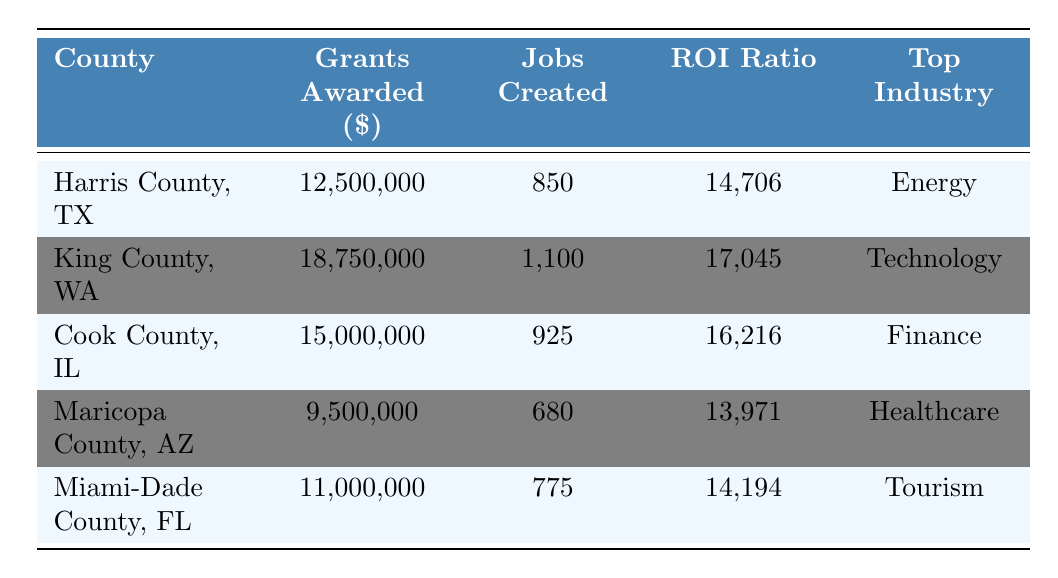What is the total amount of grants awarded across all counties? To find the total grants awarded, add the grants for each county: 12,500,000 + 18,750,000 + 15,000,000 + 9,500,000 + 11,000,000 = 66,750,000.
Answer: 66,750,000 Which county received the highest amount of grants? Look at the grants awarded column and identify the maximum value, which is 18,750,000 for King County, WA.
Answer: King County, WA What is the average number of jobs created across the counties? To find the average, sum the jobs created: 850 + 1100 + 925 + 680 + 775 = 4330, then divide by the number of counties (5): 4330 / 5 = 866.
Answer: 866 Which county has the highest ROI ratio? The highest ROI ratio is found by comparing the ROI ratios of each county. The maximum is 17,045 for King County, WA.
Answer: King County, WA Is the top industry for Maricopa County, AZ healthcare? Checking the table, the top industry for Maricopa County, AZ is indeed healthcare.
Answer: Yes What is the relationship between grants awarded and jobs created in terms of ROI? Calculate the ROI by dividing grants awarded by jobs created for each county: Harris County = 12500000/850 = 14706, King County = 18750000/1100 = 17045, Cook County = 15000000/925 = 16216, Maricopa County = 9500000/680 = 13971, Miami-Dade County = 11000000/775 = 14194. The county with the highest ROI ratio also created the most jobs per grant received.
Answer: King County, WA has the highest ROI with jobs created being in a similar proportion How many more jobs were created in King County compared to Maricopa County? Find the difference in jobs created: King County jobs (1100) - Maricopa County jobs (680) = 420.
Answer: 420 Does any county have fewer than 700 jobs created? Check the jobs created column. Maricopa County has 680, which is fewer than 700.
Answer: Yes What is the total ROI ratio for all counties combined? The total ROI ratio isn't directly calculable from provided data since it requires dividing the total grants by the total jobs created: (66,750,000 / 4,330) = 15,426.
Answer: 15,426 What is the county with the lowest number of jobs created and what is that number? Scan the jobs created column to find the minimum, which is 680 for Maricopa County, AZ.
Answer: Maricopa County, AZ with 680 jobs created 